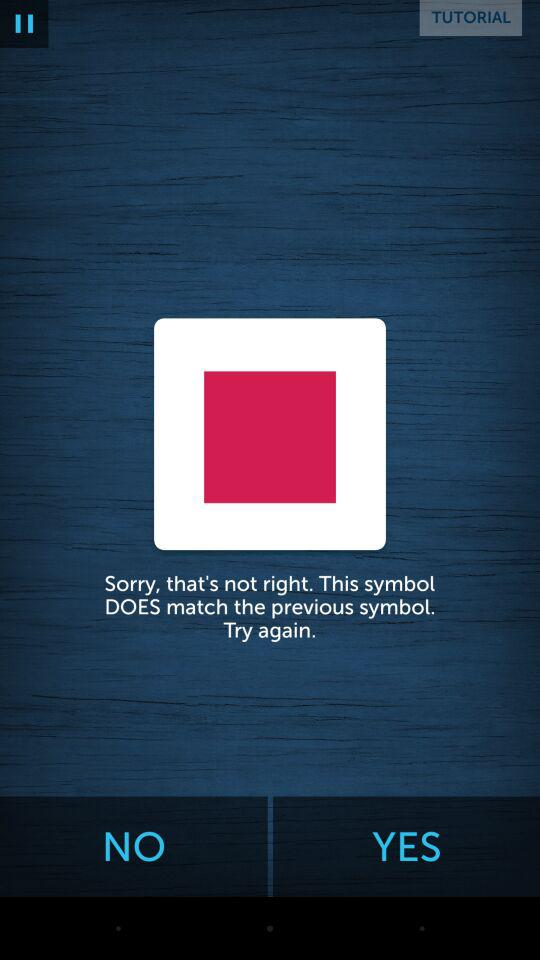How many ways are there to sign up with the app?
Answer the question using a single word or phrase. 2 